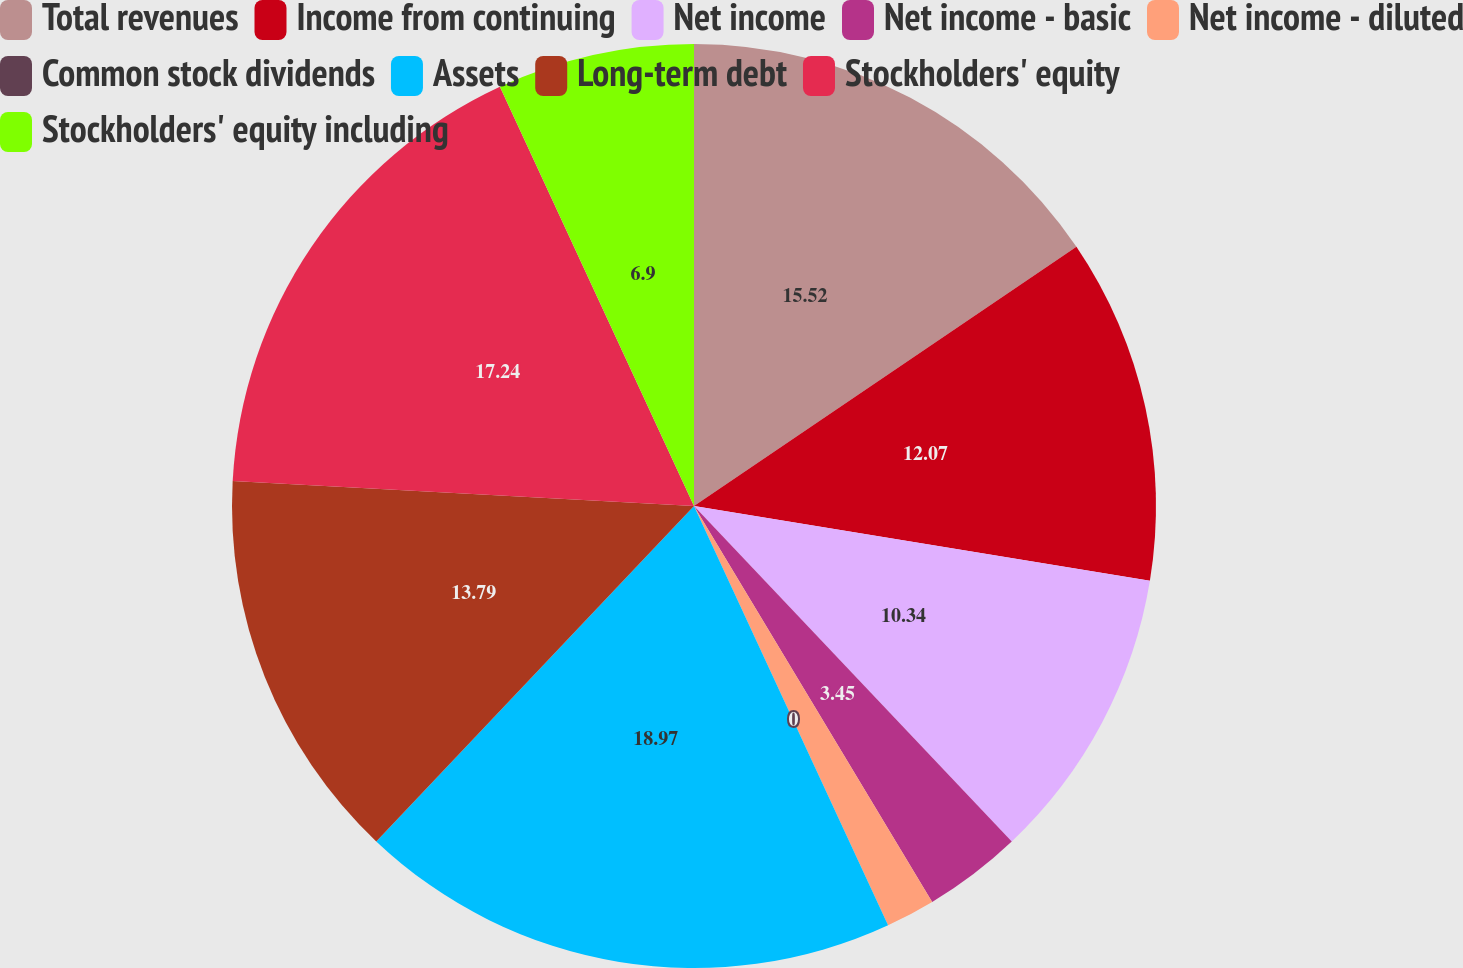Convert chart. <chart><loc_0><loc_0><loc_500><loc_500><pie_chart><fcel>Total revenues<fcel>Income from continuing<fcel>Net income<fcel>Net income - basic<fcel>Net income - diluted<fcel>Common stock dividends<fcel>Assets<fcel>Long-term debt<fcel>Stockholders' equity<fcel>Stockholders' equity including<nl><fcel>15.52%<fcel>12.07%<fcel>10.34%<fcel>3.45%<fcel>1.72%<fcel>0.0%<fcel>18.97%<fcel>13.79%<fcel>17.24%<fcel>6.9%<nl></chart> 